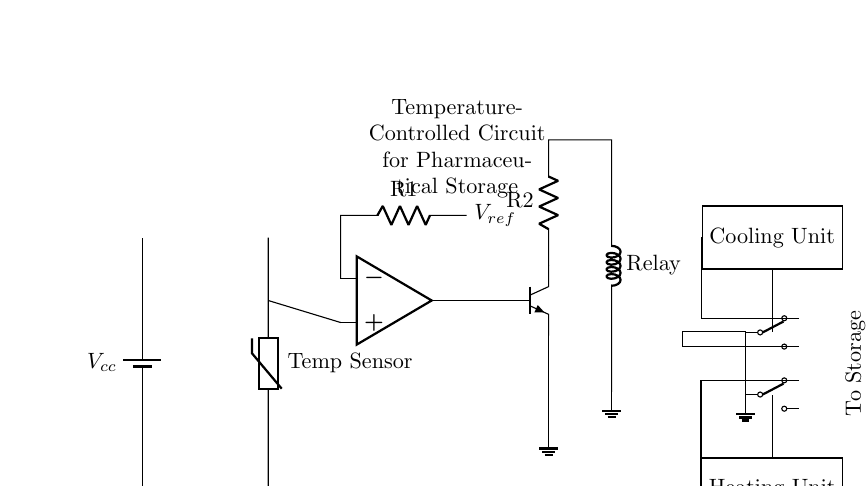What is the main function of this circuit? The main function of this circuit is to control the temperature for pharmaceutical storage units, ensuring the proper environmental conditions for the products.
Answer: Temperature control What type of temperature sensor is used in the circuit? The circuit employs a thermistor as the temperature sensor, indicated in the diagram by the label "Temp Sensor."
Answer: Thermistor What does the op-amp component do in this circuit? The operational amplifier compares the voltage from the temperature sensor with a reference voltage, and based on this comparison, it controls the transistor to activate cooling or heating units.
Answer: Comparisons What is the purpose of the relay in the circuit? The relay acts as a switch to control the power flow to the cooling unit, allowing it to turn on or off based on the signals received from the transistor, which is controlled by the op-amp.
Answer: Switching How does the circuit decide whether to heat or cool the storage unit? The decision to heat or cool is made based on the temperature reading from the thermistor compared to the reference voltage set at R1. If the temperature is too high, the op-amp activates the cooling unit; if too low, it activates the heating unit.
Answer: Temperature comparison What component connects to the ground in this circuit? The emitter of the transistor, which is connected to the ground, provides a return path for the current, completing the circuit for the cooling system.
Answer: Transistor emitter What is the role of the reference voltage in this circuit? The reference voltage provides a threshold against which the output from the thermistor is compared; this threshold determines whether heating or cooling should be activated based on the temperature.
Answer: Threshold for comparison 